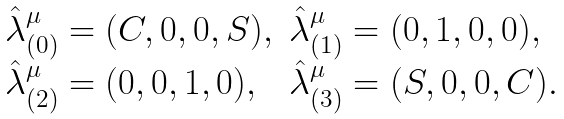<formula> <loc_0><loc_0><loc_500><loc_500>\begin{array} { l l } \hat { \lambda } ^ { \mu } _ { ( 0 ) } = ( C , 0 , 0 , S ) , & \hat { \lambda } ^ { \mu } _ { ( 1 ) } = ( 0 , 1 , 0 , 0 ) , \\ \hat { \lambda } ^ { \mu } _ { ( 2 ) } = ( 0 , 0 , 1 , 0 ) , & \hat { \lambda } ^ { \mu } _ { ( 3 ) } = ( S , 0 , 0 , C ) . \end{array}</formula> 